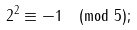<formula> <loc_0><loc_0><loc_500><loc_500>2 ^ { 2 } \equiv - 1 { \pmod { 5 } } ;</formula> 